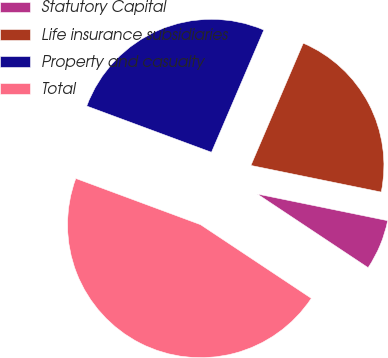<chart> <loc_0><loc_0><loc_500><loc_500><pie_chart><fcel>Statutory Capital<fcel>Life insurance subsidiaries<fcel>Property and casualty<fcel>Total<nl><fcel>6.13%<fcel>21.77%<fcel>25.79%<fcel>46.31%<nl></chart> 